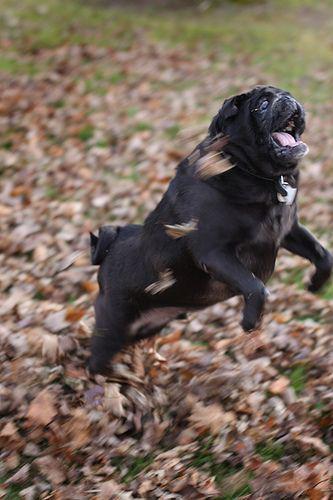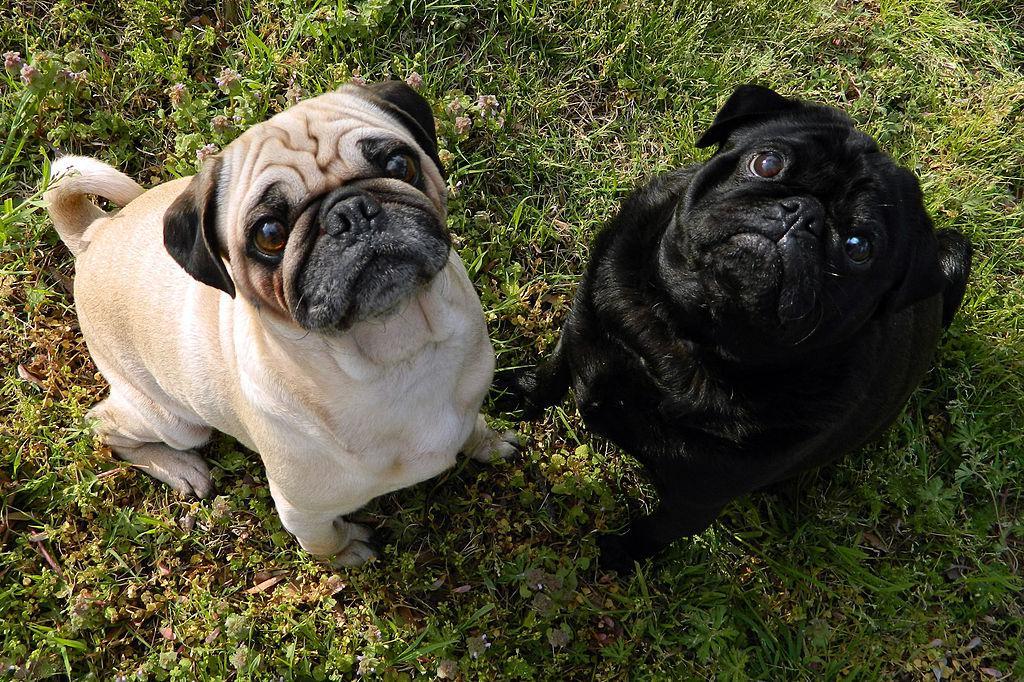The first image is the image on the left, the second image is the image on the right. Considering the images on both sides, is "Two dogs are sitting in the grass in one of the images." valid? Answer yes or no. Yes. The first image is the image on the left, the second image is the image on the right. For the images shown, is this caption "There are exactly two dogs on the grass in the image on the right." true? Answer yes or no. Yes. 